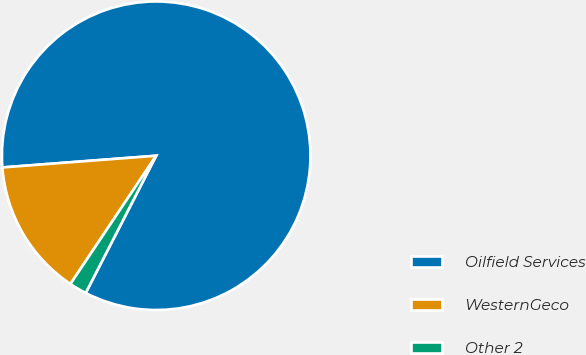Convert chart. <chart><loc_0><loc_0><loc_500><loc_500><pie_chart><fcel>Oilfield Services<fcel>WesternGeco<fcel>Other 2<nl><fcel>83.76%<fcel>14.41%<fcel>1.83%<nl></chart> 